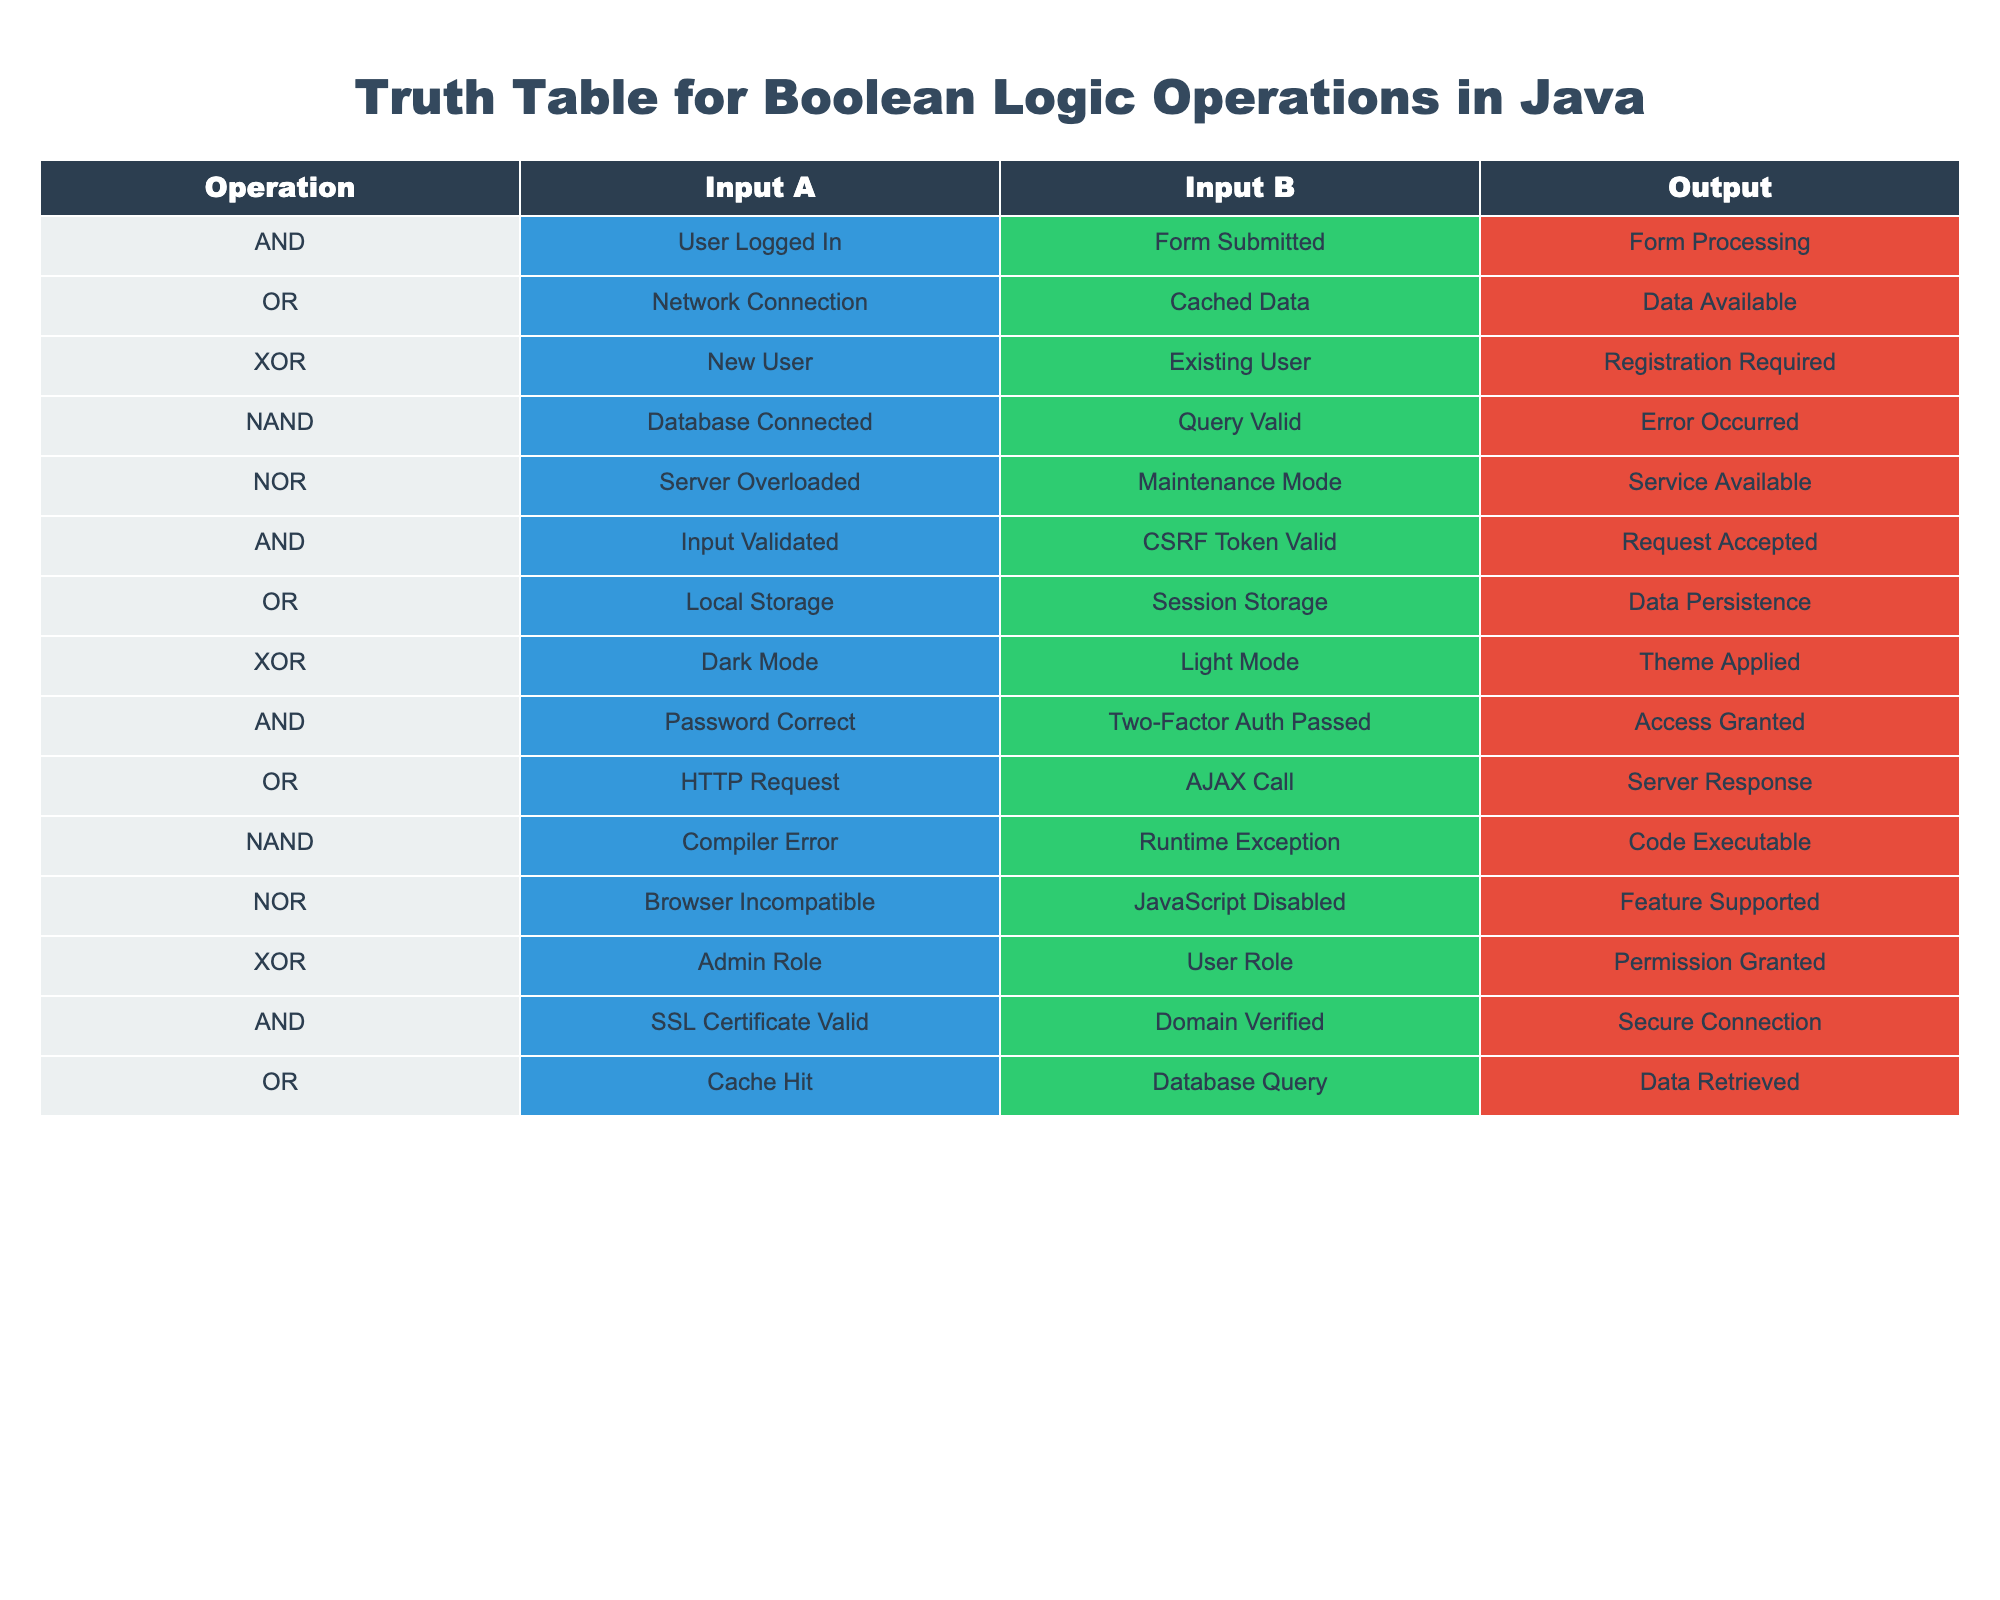What are the outputs for the AND operation? The AND operation has two instances in the table. The outputs are "Form Processing" for the first instance and "Request Accepted" for the second instance.
Answer: Form Processing, Request Accepted Is there a case where the OR operation results in "Service Available"? Looking through the OR operation rows, none of them display "Service Available" as an output. Instead, the outputs are "Data Available," "Data Persistence," and "Server Response."
Answer: No How many times does the NAND operation occur in the table? The NAND operation appears twice in the table. We can find it in two different scenarios, indicating "Error Occurred" and "Code Executable."
Answer: 2 Which operation has "Permission Granted" as its output, and what are its inputs? The XOR operation has "Permission Granted" as its output. The inputs for this operation are "Admin Role" and "User Role" based on the row in the table.
Answer: XOR with inputs Admin Role, User Role What is the output when both inputs are valid and valid for the AND operation? For the specific row with valid inputs (Input Validated and CSRF Token Valid), the AND operation's output is "Request Accepted." To find this, we can directly check the corresponding output in the given row for the AND operation.
Answer: Request Accepted Does any operation lead to "Data Retrieved"? Yes, the OR operation leads to "Data Retrieved" when the inputs are "Cache Hit" and "Database Query." We can find this by checking the OR operation section of the table.
Answer: Yes What is the relationship between the XOR operation results of "Registration Required" and "Permission Granted"? Both outputs stem from XOR operations, but they concern different input pairs. "Registration Required" comes from the inputs of "New User" and "Existing User," while "Permission Granted" involves "Admin Role" and "User Role." These outputs indicate mutually exclusive scenarios.
Answer: Different input pairs lead to different outputs How would you categorize the outputs of the NOR operations in terms of functionality? Both outputs of NOR operations focus on system status; "Service Available" means normal operation despite potential issues, while "Feature Supported" indicates functionality under specific conditions (incompatibility or disabled services). Hence, both relate to system functionality status.
Answer: System functionality status 